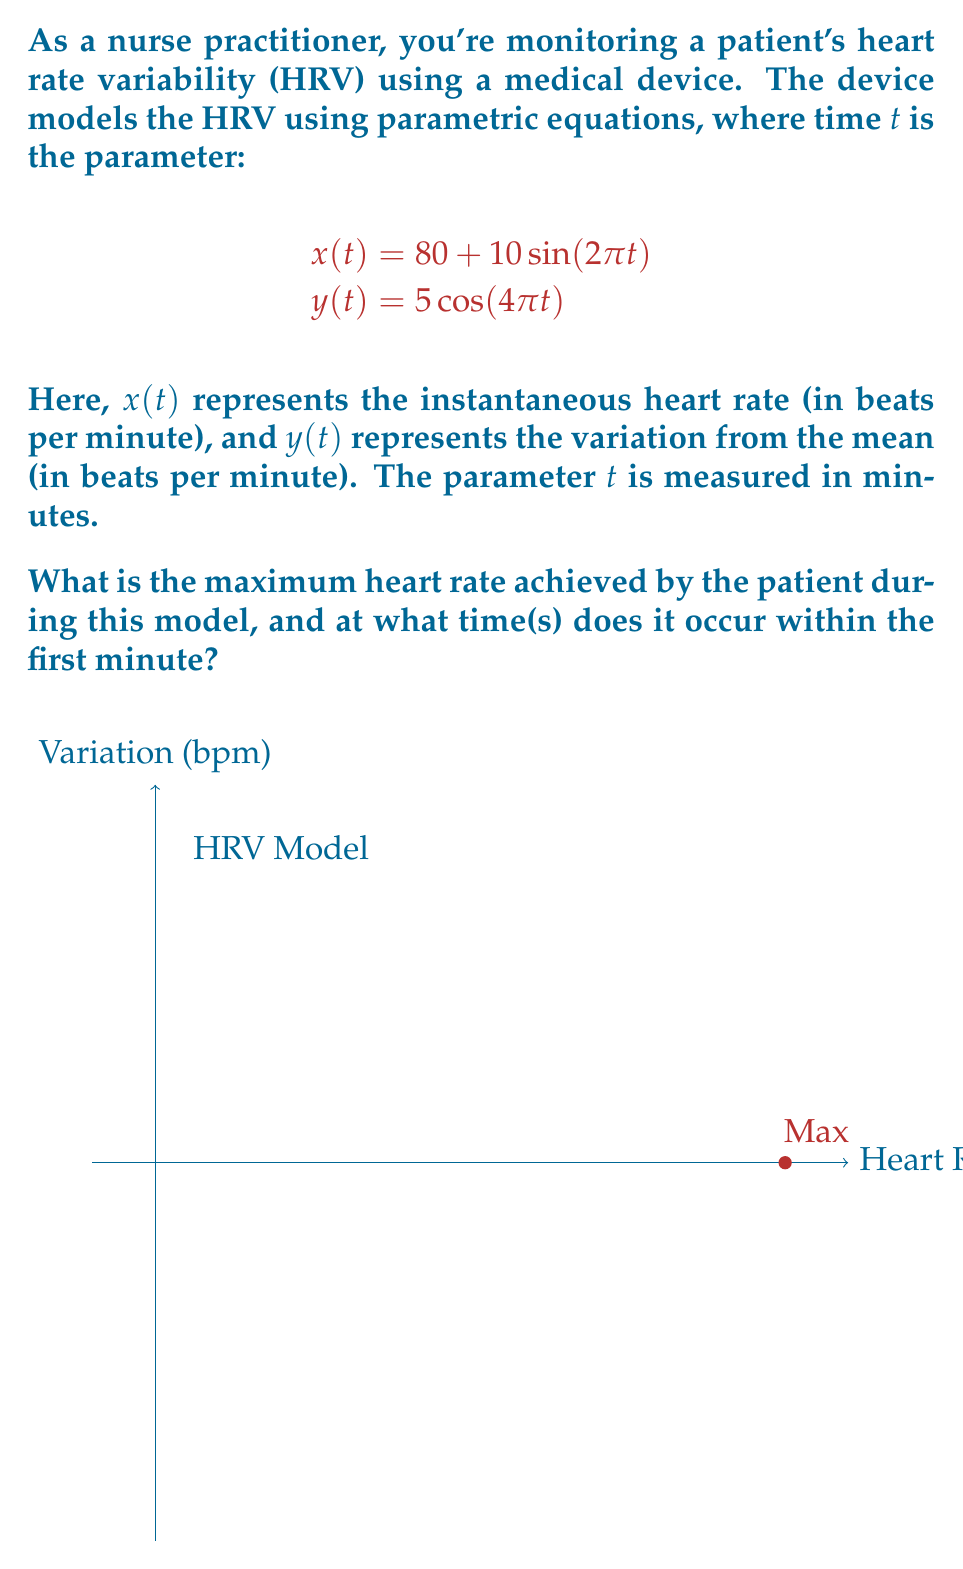Provide a solution to this math problem. To solve this problem, let's follow these steps:

1) The instantaneous heart rate is given by $x(t) = 80 + 10\sin(2\pi t)$. We need to find the maximum value of this function.

2) The maximum value of sine is 1, which occurs when its argument is $\frac{\pi}{2} + 2\pi n$, where $n$ is any integer.

3) So, we need to solve:
   $2\pi t = \frac{\pi}{2} + 2\pi n$
   $t = \frac{1}{4} + n$, where $n$ is any integer

4) Within the first minute (0 ≤ t < 1), this occurs when $t = \frac{1}{4}$ (n = 0).

5) At this time, the maximum heart rate is:
   $x(\frac{1}{4}) = 80 + 10\sin(2\pi \cdot \frac{1}{4}) = 80 + 10 \cdot 1 = 90$ bpm

6) To verify this is indeed the maximum, we can check the derivative:
   $\frac{dx}{dt} = 20\pi\cos(2\pi t)$
   This is zero when $\cos(2\pi t) = 0$, which occurs at $t = \frac{1}{4}$ and $t = \frac{3}{4}$ in the first minute.
   The second derivative at $t = \frac{1}{4}$ is negative, confirming it's a maximum.

Therefore, the maximum heart rate is 90 bpm, occurring at $t = \frac{1}{4}$ minute (or 15 seconds) within the first minute.
Answer: 90 bpm at t = 1/4 minute 